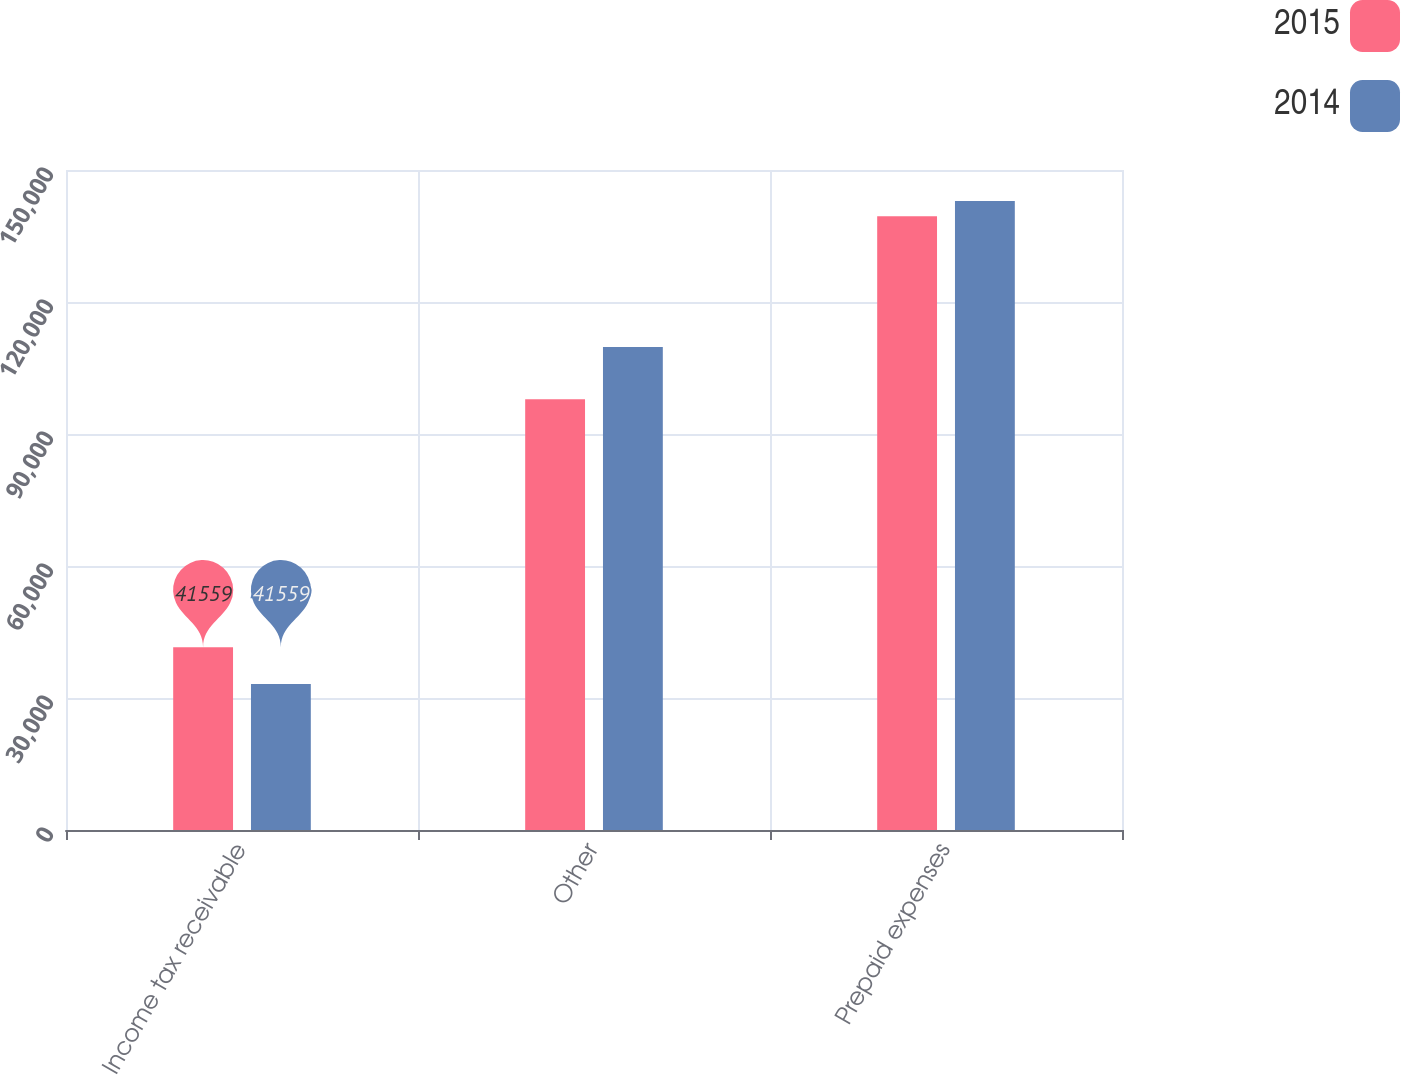Convert chart to OTSL. <chart><loc_0><loc_0><loc_500><loc_500><stacked_bar_chart><ecel><fcel>Income tax receivable<fcel>Other<fcel>Prepaid expenses<nl><fcel>2015<fcel>41559<fcel>97910<fcel>139469<nl><fcel>2014<fcel>33173<fcel>109778<fcel>142951<nl></chart> 